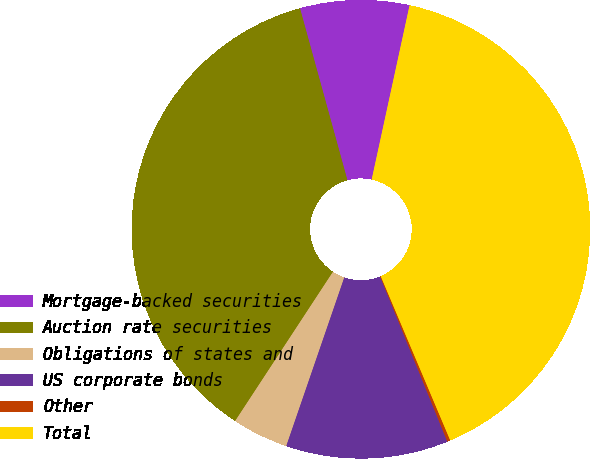Convert chart. <chart><loc_0><loc_0><loc_500><loc_500><pie_chart><fcel>Mortgage-backed securities<fcel>Auction rate securities<fcel>Obligations of states and<fcel>US corporate bonds<fcel>Other<fcel>Total<nl><fcel>7.69%<fcel>36.48%<fcel>3.96%<fcel>11.43%<fcel>0.22%<fcel>40.22%<nl></chart> 